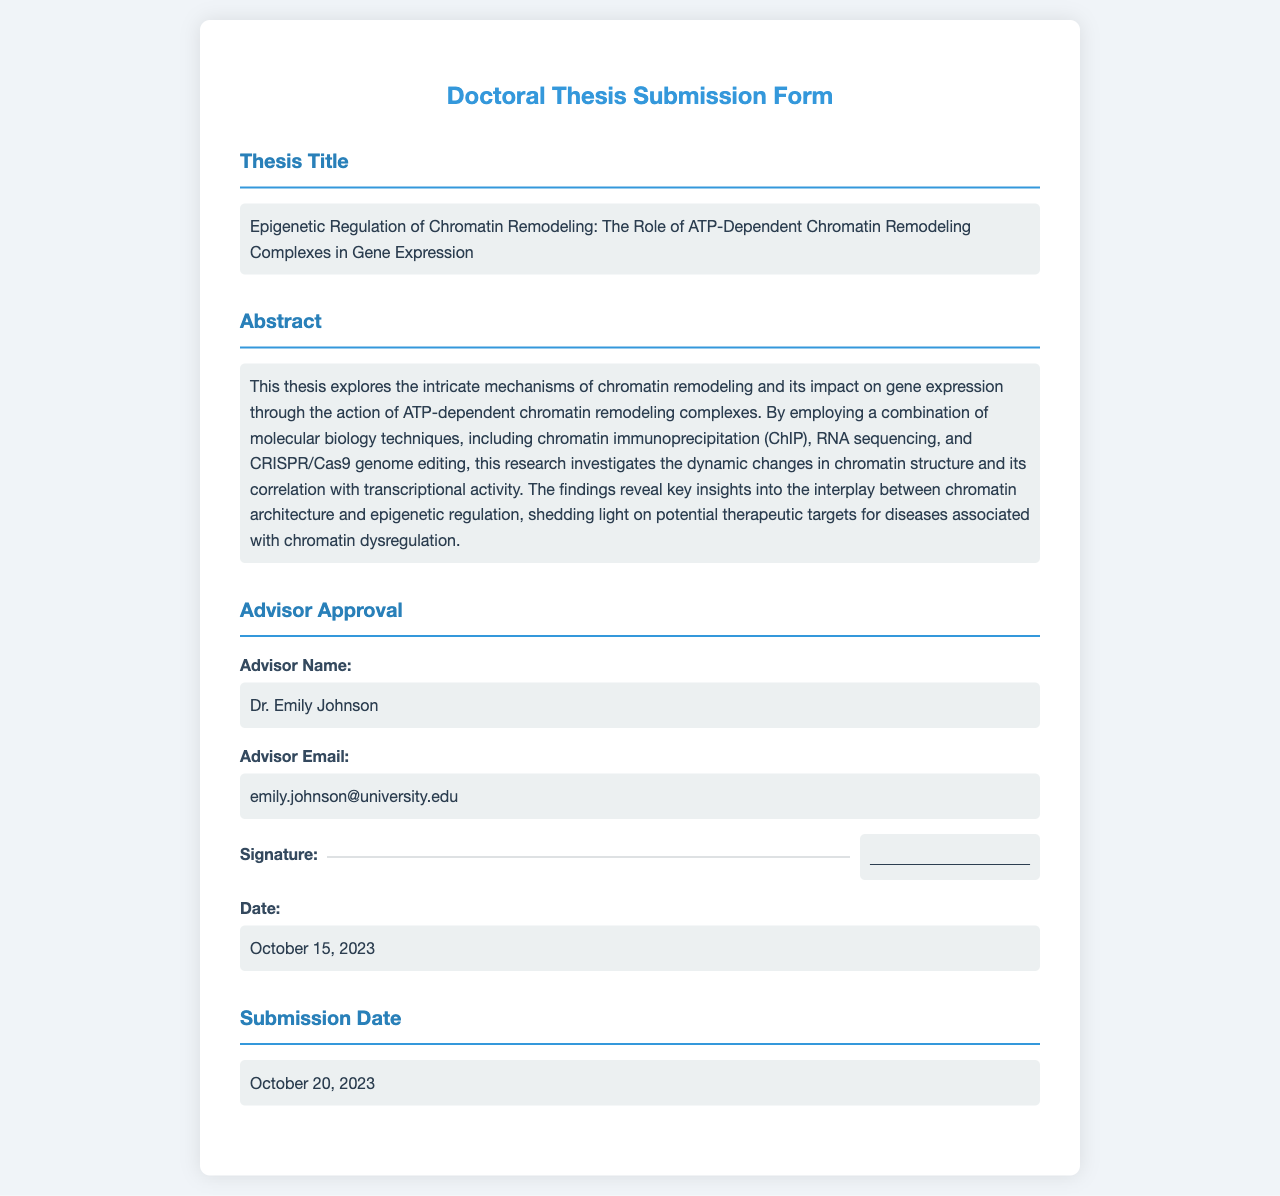What is the title of the thesis? The title of the thesis is clearly stated in the document, under the "Thesis Title" section.
Answer: Epigenetic Regulation of Chromatin Remodeling: The Role of ATP-Dependent Chromatin Remodeling Complexes in Gene Expression Who is the advisor? The advisor's name is provided in the "Advisor Approval" section of the document.
Answer: Dr. Emily Johnson What is the submission date? The submission date is specified in the "Submission Date" section of the document.
Answer: October 20, 2023 What date did the advisor sign? The date on which the advisor's approval was given is located in the "Advisor Approval" section.
Answer: October 15, 2023 What type of research techniques were used in the thesis? The abstract mentions the specific molecular biology techniques employed in the research.
Answer: chromatin immunoprecipitation, RNA sequencing, CRISPR/Cas9 genome editing How does the thesis relate to disease? The abstract describes the implications of the research, particularly mentioning therapeutic targets for diseases.
Answer: chromatin dysregulation What is the email of the advisor? The advisor's email is listed in the "Advisor Approval" section.
Answer: emily.johnson@university.edu What is the main focus of the thesis? The abstract summarizes the primary focus of the research regarding chromatin remodeling and gene expression.
Answer: chromatin remodeling and its impact on gene expression 